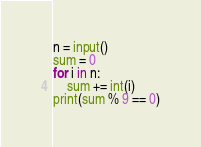Convert code to text. <code><loc_0><loc_0><loc_500><loc_500><_Python_>n = input()
sum = 0
for i in n:
    sum += int(i)
print(sum % 9 == 0)</code> 